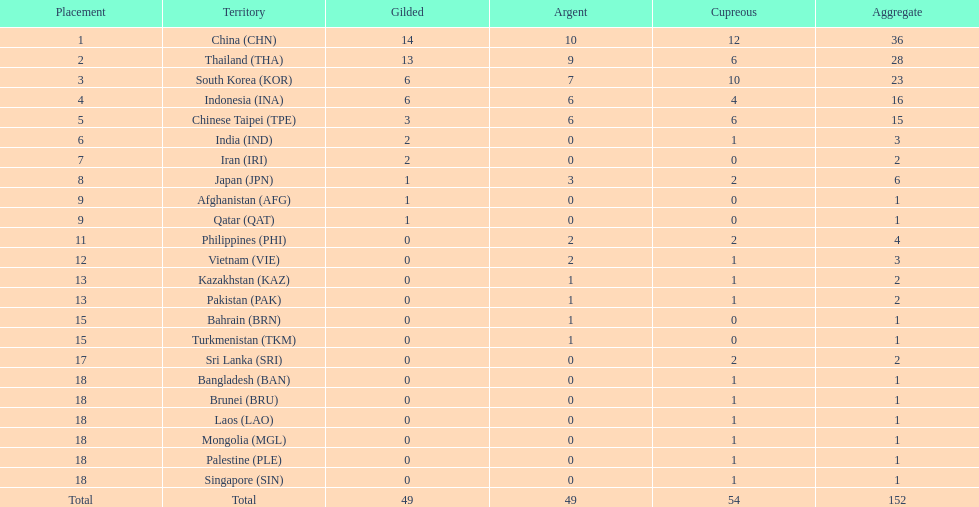Which nation finished first in total medals earned? China (CHN). 